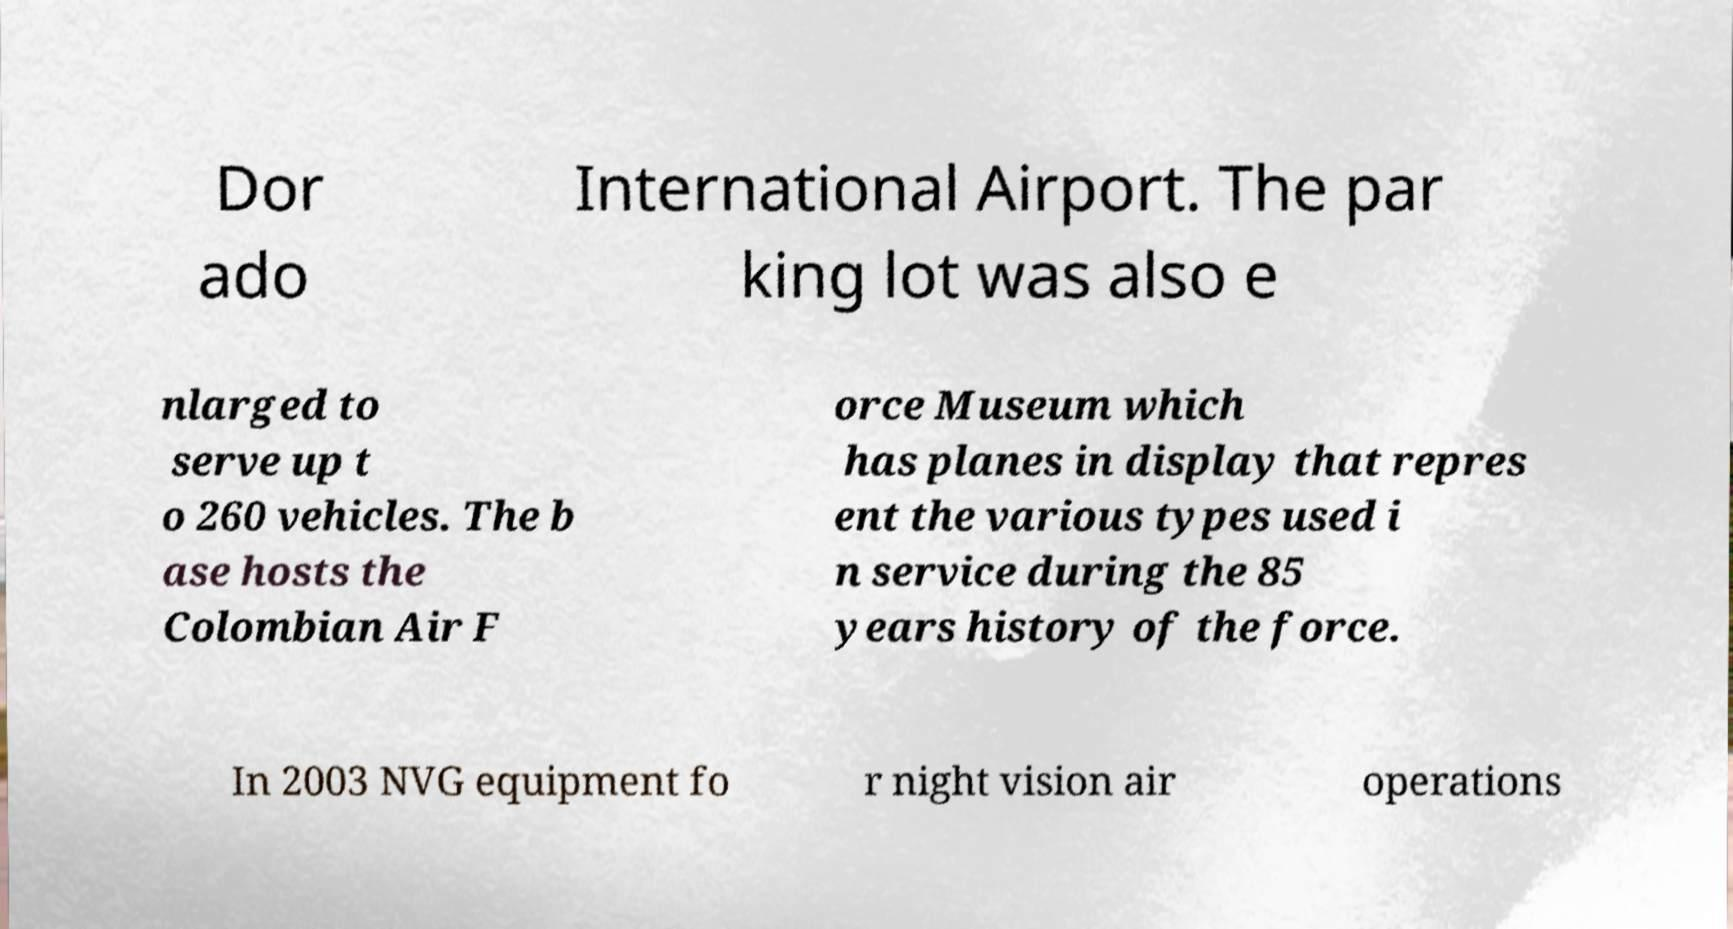Could you extract and type out the text from this image? Dor ado International Airport. The par king lot was also e nlarged to serve up t o 260 vehicles. The b ase hosts the Colombian Air F orce Museum which has planes in display that repres ent the various types used i n service during the 85 years history of the force. In 2003 NVG equipment fo r night vision air operations 